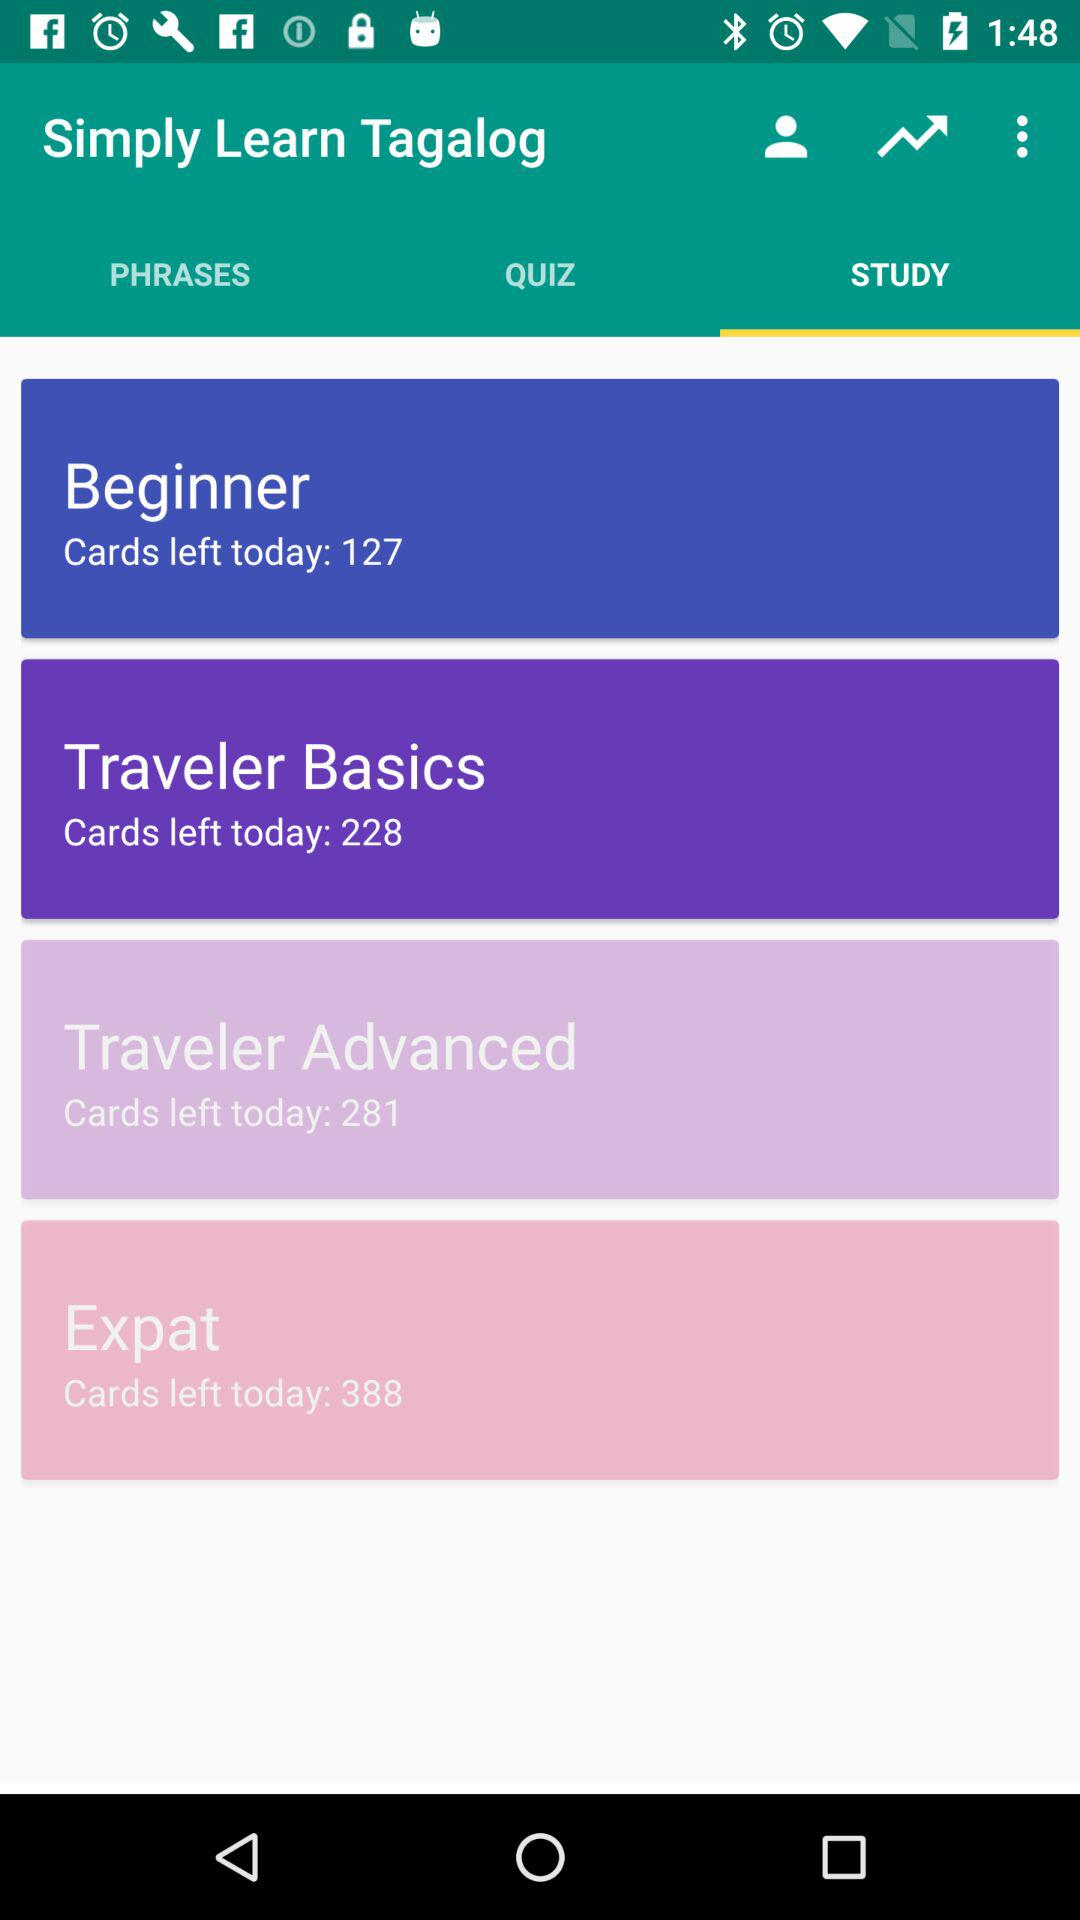How many cards are left in the "Traveler Basics" category? There are 228 cards left in the "Traveler Basics" category. 